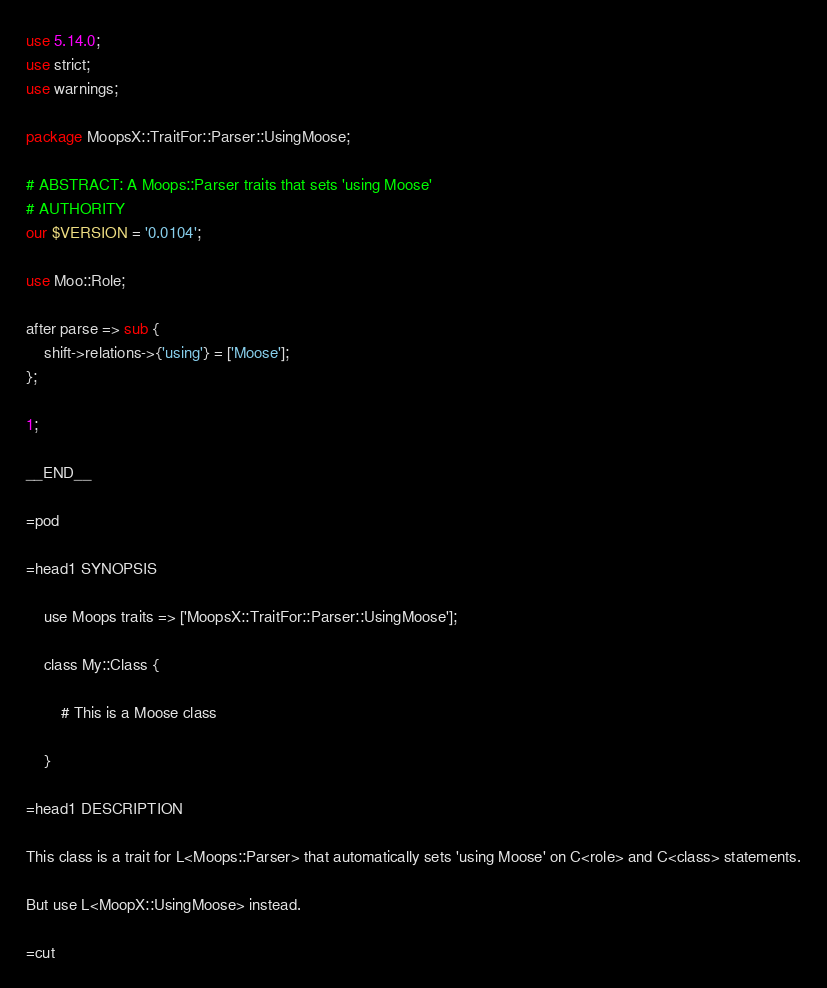<code> <loc_0><loc_0><loc_500><loc_500><_Perl_>use 5.14.0;
use strict;
use warnings;

package MoopsX::TraitFor::Parser::UsingMoose;

# ABSTRACT: A Moops::Parser traits that sets 'using Moose'
# AUTHORITY
our $VERSION = '0.0104';

use Moo::Role;

after parse => sub {
    shift->relations->{'using'} = ['Moose'];
};

1;

__END__

=pod

=head1 SYNOPSIS

    use Moops traits => ['MoopsX::TraitFor::Parser::UsingMoose'];

    class My::Class {

        # This is a Moose class

    }

=head1 DESCRIPTION

This class is a trait for L<Moops::Parser> that automatically sets 'using Moose' on C<role> and C<class> statements.

But use L<MoopX::UsingMoose> instead.

=cut
</code> 